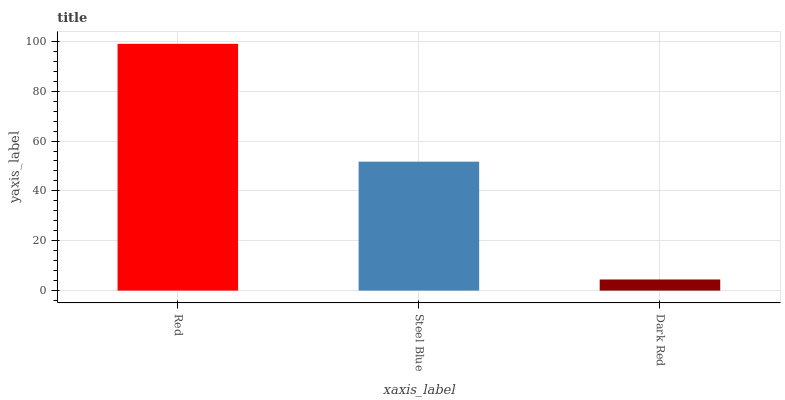Is Dark Red the minimum?
Answer yes or no. Yes. Is Red the maximum?
Answer yes or no. Yes. Is Steel Blue the minimum?
Answer yes or no. No. Is Steel Blue the maximum?
Answer yes or no. No. Is Red greater than Steel Blue?
Answer yes or no. Yes. Is Steel Blue less than Red?
Answer yes or no. Yes. Is Steel Blue greater than Red?
Answer yes or no. No. Is Red less than Steel Blue?
Answer yes or no. No. Is Steel Blue the high median?
Answer yes or no. Yes. Is Steel Blue the low median?
Answer yes or no. Yes. Is Dark Red the high median?
Answer yes or no. No. Is Dark Red the low median?
Answer yes or no. No. 